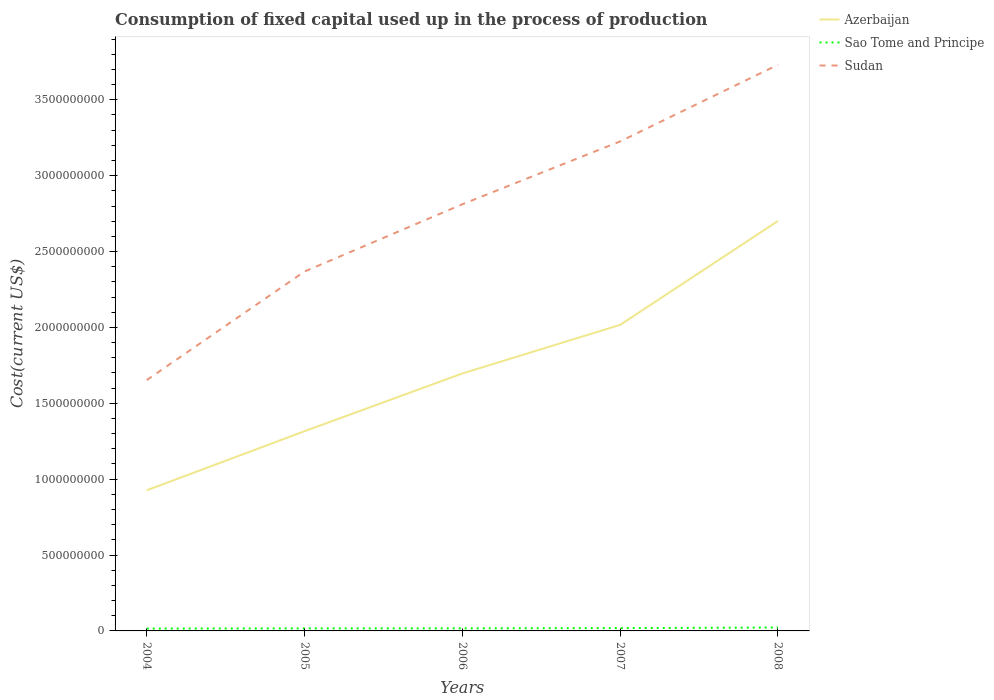Is the number of lines equal to the number of legend labels?
Your answer should be very brief. Yes. Across all years, what is the maximum amount consumed in the process of production in Sao Tome and Principe?
Your answer should be compact. 1.56e+07. What is the total amount consumed in the process of production in Sao Tome and Principe in the graph?
Keep it short and to the point. -6.07e+06. What is the difference between the highest and the second highest amount consumed in the process of production in Sao Tome and Principe?
Make the answer very short. 7.11e+06. What is the difference between the highest and the lowest amount consumed in the process of production in Sao Tome and Principe?
Give a very brief answer. 2. How many lines are there?
Your answer should be compact. 3. Does the graph contain any zero values?
Give a very brief answer. No. Does the graph contain grids?
Offer a very short reply. No. Where does the legend appear in the graph?
Your answer should be very brief. Top right. What is the title of the graph?
Keep it short and to the point. Consumption of fixed capital used up in the process of production. Does "Cameroon" appear as one of the legend labels in the graph?
Make the answer very short. No. What is the label or title of the Y-axis?
Offer a very short reply. Cost(current US$). What is the Cost(current US$) in Azerbaijan in 2004?
Give a very brief answer. 9.27e+08. What is the Cost(current US$) in Sao Tome and Principe in 2004?
Provide a succinct answer. 1.56e+07. What is the Cost(current US$) in Sudan in 2004?
Provide a succinct answer. 1.65e+09. What is the Cost(current US$) in Azerbaijan in 2005?
Your answer should be very brief. 1.32e+09. What is the Cost(current US$) in Sao Tome and Principe in 2005?
Make the answer very short. 1.66e+07. What is the Cost(current US$) in Sudan in 2005?
Offer a terse response. 2.37e+09. What is the Cost(current US$) of Azerbaijan in 2006?
Your answer should be very brief. 1.70e+09. What is the Cost(current US$) of Sao Tome and Principe in 2006?
Ensure brevity in your answer.  1.69e+07. What is the Cost(current US$) in Sudan in 2006?
Your answer should be very brief. 2.81e+09. What is the Cost(current US$) of Azerbaijan in 2007?
Provide a succinct answer. 2.02e+09. What is the Cost(current US$) of Sao Tome and Principe in 2007?
Give a very brief answer. 1.85e+07. What is the Cost(current US$) of Sudan in 2007?
Your answer should be compact. 3.23e+09. What is the Cost(current US$) of Azerbaijan in 2008?
Provide a short and direct response. 2.70e+09. What is the Cost(current US$) of Sao Tome and Principe in 2008?
Keep it short and to the point. 2.27e+07. What is the Cost(current US$) in Sudan in 2008?
Your answer should be very brief. 3.73e+09. Across all years, what is the maximum Cost(current US$) of Azerbaijan?
Give a very brief answer. 2.70e+09. Across all years, what is the maximum Cost(current US$) in Sao Tome and Principe?
Offer a very short reply. 2.27e+07. Across all years, what is the maximum Cost(current US$) of Sudan?
Offer a terse response. 3.73e+09. Across all years, what is the minimum Cost(current US$) of Azerbaijan?
Give a very brief answer. 9.27e+08. Across all years, what is the minimum Cost(current US$) of Sao Tome and Principe?
Your answer should be very brief. 1.56e+07. Across all years, what is the minimum Cost(current US$) in Sudan?
Your response must be concise. 1.65e+09. What is the total Cost(current US$) in Azerbaijan in the graph?
Ensure brevity in your answer.  8.66e+09. What is the total Cost(current US$) in Sao Tome and Principe in the graph?
Ensure brevity in your answer.  9.03e+07. What is the total Cost(current US$) of Sudan in the graph?
Your answer should be compact. 1.38e+1. What is the difference between the Cost(current US$) in Azerbaijan in 2004 and that in 2005?
Your answer should be compact. -3.89e+08. What is the difference between the Cost(current US$) in Sao Tome and Principe in 2004 and that in 2005?
Give a very brief answer. -1.04e+06. What is the difference between the Cost(current US$) in Sudan in 2004 and that in 2005?
Ensure brevity in your answer.  -7.15e+08. What is the difference between the Cost(current US$) of Azerbaijan in 2004 and that in 2006?
Your response must be concise. -7.70e+08. What is the difference between the Cost(current US$) in Sao Tome and Principe in 2004 and that in 2006?
Offer a terse response. -1.29e+06. What is the difference between the Cost(current US$) of Sudan in 2004 and that in 2006?
Keep it short and to the point. -1.16e+09. What is the difference between the Cost(current US$) in Azerbaijan in 2004 and that in 2007?
Provide a succinct answer. -1.09e+09. What is the difference between the Cost(current US$) of Sao Tome and Principe in 2004 and that in 2007?
Provide a succinct answer. -2.95e+06. What is the difference between the Cost(current US$) of Sudan in 2004 and that in 2007?
Make the answer very short. -1.57e+09. What is the difference between the Cost(current US$) of Azerbaijan in 2004 and that in 2008?
Ensure brevity in your answer.  -1.77e+09. What is the difference between the Cost(current US$) of Sao Tome and Principe in 2004 and that in 2008?
Give a very brief answer. -7.11e+06. What is the difference between the Cost(current US$) in Sudan in 2004 and that in 2008?
Your response must be concise. -2.08e+09. What is the difference between the Cost(current US$) in Azerbaijan in 2005 and that in 2006?
Your answer should be compact. -3.80e+08. What is the difference between the Cost(current US$) of Sao Tome and Principe in 2005 and that in 2006?
Make the answer very short. -2.56e+05. What is the difference between the Cost(current US$) in Sudan in 2005 and that in 2006?
Make the answer very short. -4.43e+08. What is the difference between the Cost(current US$) of Azerbaijan in 2005 and that in 2007?
Give a very brief answer. -7.01e+08. What is the difference between the Cost(current US$) of Sao Tome and Principe in 2005 and that in 2007?
Your response must be concise. -1.92e+06. What is the difference between the Cost(current US$) of Sudan in 2005 and that in 2007?
Provide a short and direct response. -8.57e+08. What is the difference between the Cost(current US$) of Azerbaijan in 2005 and that in 2008?
Your response must be concise. -1.39e+09. What is the difference between the Cost(current US$) of Sao Tome and Principe in 2005 and that in 2008?
Provide a short and direct response. -6.07e+06. What is the difference between the Cost(current US$) in Sudan in 2005 and that in 2008?
Give a very brief answer. -1.36e+09. What is the difference between the Cost(current US$) in Azerbaijan in 2006 and that in 2007?
Your answer should be compact. -3.20e+08. What is the difference between the Cost(current US$) of Sao Tome and Principe in 2006 and that in 2007?
Ensure brevity in your answer.  -1.66e+06. What is the difference between the Cost(current US$) of Sudan in 2006 and that in 2007?
Your response must be concise. -4.14e+08. What is the difference between the Cost(current US$) in Azerbaijan in 2006 and that in 2008?
Ensure brevity in your answer.  -1.01e+09. What is the difference between the Cost(current US$) in Sao Tome and Principe in 2006 and that in 2008?
Your response must be concise. -5.82e+06. What is the difference between the Cost(current US$) of Sudan in 2006 and that in 2008?
Your response must be concise. -9.19e+08. What is the difference between the Cost(current US$) in Azerbaijan in 2007 and that in 2008?
Keep it short and to the point. -6.85e+08. What is the difference between the Cost(current US$) in Sao Tome and Principe in 2007 and that in 2008?
Provide a succinct answer. -4.15e+06. What is the difference between the Cost(current US$) in Sudan in 2007 and that in 2008?
Offer a terse response. -5.05e+08. What is the difference between the Cost(current US$) in Azerbaijan in 2004 and the Cost(current US$) in Sao Tome and Principe in 2005?
Offer a very short reply. 9.10e+08. What is the difference between the Cost(current US$) of Azerbaijan in 2004 and the Cost(current US$) of Sudan in 2005?
Give a very brief answer. -1.44e+09. What is the difference between the Cost(current US$) in Sao Tome and Principe in 2004 and the Cost(current US$) in Sudan in 2005?
Give a very brief answer. -2.35e+09. What is the difference between the Cost(current US$) of Azerbaijan in 2004 and the Cost(current US$) of Sao Tome and Principe in 2006?
Ensure brevity in your answer.  9.10e+08. What is the difference between the Cost(current US$) in Azerbaijan in 2004 and the Cost(current US$) in Sudan in 2006?
Make the answer very short. -1.89e+09. What is the difference between the Cost(current US$) of Sao Tome and Principe in 2004 and the Cost(current US$) of Sudan in 2006?
Give a very brief answer. -2.80e+09. What is the difference between the Cost(current US$) of Azerbaijan in 2004 and the Cost(current US$) of Sao Tome and Principe in 2007?
Provide a succinct answer. 9.08e+08. What is the difference between the Cost(current US$) of Azerbaijan in 2004 and the Cost(current US$) of Sudan in 2007?
Ensure brevity in your answer.  -2.30e+09. What is the difference between the Cost(current US$) of Sao Tome and Principe in 2004 and the Cost(current US$) of Sudan in 2007?
Provide a short and direct response. -3.21e+09. What is the difference between the Cost(current US$) in Azerbaijan in 2004 and the Cost(current US$) in Sao Tome and Principe in 2008?
Ensure brevity in your answer.  9.04e+08. What is the difference between the Cost(current US$) of Azerbaijan in 2004 and the Cost(current US$) of Sudan in 2008?
Ensure brevity in your answer.  -2.80e+09. What is the difference between the Cost(current US$) in Sao Tome and Principe in 2004 and the Cost(current US$) in Sudan in 2008?
Offer a very short reply. -3.72e+09. What is the difference between the Cost(current US$) of Azerbaijan in 2005 and the Cost(current US$) of Sao Tome and Principe in 2006?
Give a very brief answer. 1.30e+09. What is the difference between the Cost(current US$) in Azerbaijan in 2005 and the Cost(current US$) in Sudan in 2006?
Your answer should be compact. -1.50e+09. What is the difference between the Cost(current US$) in Sao Tome and Principe in 2005 and the Cost(current US$) in Sudan in 2006?
Your answer should be very brief. -2.80e+09. What is the difference between the Cost(current US$) in Azerbaijan in 2005 and the Cost(current US$) in Sao Tome and Principe in 2007?
Your response must be concise. 1.30e+09. What is the difference between the Cost(current US$) in Azerbaijan in 2005 and the Cost(current US$) in Sudan in 2007?
Provide a short and direct response. -1.91e+09. What is the difference between the Cost(current US$) in Sao Tome and Principe in 2005 and the Cost(current US$) in Sudan in 2007?
Offer a very short reply. -3.21e+09. What is the difference between the Cost(current US$) in Azerbaijan in 2005 and the Cost(current US$) in Sao Tome and Principe in 2008?
Provide a short and direct response. 1.29e+09. What is the difference between the Cost(current US$) of Azerbaijan in 2005 and the Cost(current US$) of Sudan in 2008?
Your answer should be compact. -2.41e+09. What is the difference between the Cost(current US$) in Sao Tome and Principe in 2005 and the Cost(current US$) in Sudan in 2008?
Ensure brevity in your answer.  -3.71e+09. What is the difference between the Cost(current US$) of Azerbaijan in 2006 and the Cost(current US$) of Sao Tome and Principe in 2007?
Your answer should be very brief. 1.68e+09. What is the difference between the Cost(current US$) of Azerbaijan in 2006 and the Cost(current US$) of Sudan in 2007?
Offer a very short reply. -1.53e+09. What is the difference between the Cost(current US$) in Sao Tome and Principe in 2006 and the Cost(current US$) in Sudan in 2007?
Provide a succinct answer. -3.21e+09. What is the difference between the Cost(current US$) in Azerbaijan in 2006 and the Cost(current US$) in Sao Tome and Principe in 2008?
Ensure brevity in your answer.  1.67e+09. What is the difference between the Cost(current US$) of Azerbaijan in 2006 and the Cost(current US$) of Sudan in 2008?
Your answer should be compact. -2.03e+09. What is the difference between the Cost(current US$) in Sao Tome and Principe in 2006 and the Cost(current US$) in Sudan in 2008?
Your answer should be very brief. -3.71e+09. What is the difference between the Cost(current US$) in Azerbaijan in 2007 and the Cost(current US$) in Sao Tome and Principe in 2008?
Your response must be concise. 1.99e+09. What is the difference between the Cost(current US$) in Azerbaijan in 2007 and the Cost(current US$) in Sudan in 2008?
Your response must be concise. -1.71e+09. What is the difference between the Cost(current US$) in Sao Tome and Principe in 2007 and the Cost(current US$) in Sudan in 2008?
Your answer should be compact. -3.71e+09. What is the average Cost(current US$) of Azerbaijan per year?
Offer a very short reply. 1.73e+09. What is the average Cost(current US$) of Sao Tome and Principe per year?
Provide a succinct answer. 1.81e+07. What is the average Cost(current US$) of Sudan per year?
Your response must be concise. 2.76e+09. In the year 2004, what is the difference between the Cost(current US$) of Azerbaijan and Cost(current US$) of Sao Tome and Principe?
Your response must be concise. 9.11e+08. In the year 2004, what is the difference between the Cost(current US$) in Azerbaijan and Cost(current US$) in Sudan?
Provide a short and direct response. -7.26e+08. In the year 2004, what is the difference between the Cost(current US$) in Sao Tome and Principe and Cost(current US$) in Sudan?
Offer a terse response. -1.64e+09. In the year 2005, what is the difference between the Cost(current US$) of Azerbaijan and Cost(current US$) of Sao Tome and Principe?
Offer a very short reply. 1.30e+09. In the year 2005, what is the difference between the Cost(current US$) of Azerbaijan and Cost(current US$) of Sudan?
Provide a succinct answer. -1.05e+09. In the year 2005, what is the difference between the Cost(current US$) of Sao Tome and Principe and Cost(current US$) of Sudan?
Your response must be concise. -2.35e+09. In the year 2006, what is the difference between the Cost(current US$) of Azerbaijan and Cost(current US$) of Sao Tome and Principe?
Give a very brief answer. 1.68e+09. In the year 2006, what is the difference between the Cost(current US$) of Azerbaijan and Cost(current US$) of Sudan?
Keep it short and to the point. -1.12e+09. In the year 2006, what is the difference between the Cost(current US$) of Sao Tome and Principe and Cost(current US$) of Sudan?
Your response must be concise. -2.79e+09. In the year 2007, what is the difference between the Cost(current US$) of Azerbaijan and Cost(current US$) of Sao Tome and Principe?
Provide a succinct answer. 2.00e+09. In the year 2007, what is the difference between the Cost(current US$) in Azerbaijan and Cost(current US$) in Sudan?
Provide a succinct answer. -1.21e+09. In the year 2007, what is the difference between the Cost(current US$) in Sao Tome and Principe and Cost(current US$) in Sudan?
Your response must be concise. -3.21e+09. In the year 2008, what is the difference between the Cost(current US$) of Azerbaijan and Cost(current US$) of Sao Tome and Principe?
Keep it short and to the point. 2.68e+09. In the year 2008, what is the difference between the Cost(current US$) of Azerbaijan and Cost(current US$) of Sudan?
Give a very brief answer. -1.03e+09. In the year 2008, what is the difference between the Cost(current US$) of Sao Tome and Principe and Cost(current US$) of Sudan?
Ensure brevity in your answer.  -3.71e+09. What is the ratio of the Cost(current US$) of Azerbaijan in 2004 to that in 2005?
Your response must be concise. 0.7. What is the ratio of the Cost(current US$) of Sao Tome and Principe in 2004 to that in 2005?
Your answer should be compact. 0.94. What is the ratio of the Cost(current US$) in Sudan in 2004 to that in 2005?
Your answer should be very brief. 0.7. What is the ratio of the Cost(current US$) of Azerbaijan in 2004 to that in 2006?
Your response must be concise. 0.55. What is the ratio of the Cost(current US$) in Sao Tome and Principe in 2004 to that in 2006?
Make the answer very short. 0.92. What is the ratio of the Cost(current US$) of Sudan in 2004 to that in 2006?
Provide a short and direct response. 0.59. What is the ratio of the Cost(current US$) of Azerbaijan in 2004 to that in 2007?
Give a very brief answer. 0.46. What is the ratio of the Cost(current US$) of Sao Tome and Principe in 2004 to that in 2007?
Provide a succinct answer. 0.84. What is the ratio of the Cost(current US$) in Sudan in 2004 to that in 2007?
Give a very brief answer. 0.51. What is the ratio of the Cost(current US$) of Azerbaijan in 2004 to that in 2008?
Your answer should be compact. 0.34. What is the ratio of the Cost(current US$) of Sao Tome and Principe in 2004 to that in 2008?
Your answer should be very brief. 0.69. What is the ratio of the Cost(current US$) in Sudan in 2004 to that in 2008?
Provide a succinct answer. 0.44. What is the ratio of the Cost(current US$) of Azerbaijan in 2005 to that in 2006?
Offer a very short reply. 0.78. What is the ratio of the Cost(current US$) in Sudan in 2005 to that in 2006?
Give a very brief answer. 0.84. What is the ratio of the Cost(current US$) in Azerbaijan in 2005 to that in 2007?
Your answer should be very brief. 0.65. What is the ratio of the Cost(current US$) of Sao Tome and Principe in 2005 to that in 2007?
Provide a short and direct response. 0.9. What is the ratio of the Cost(current US$) in Sudan in 2005 to that in 2007?
Offer a very short reply. 0.73. What is the ratio of the Cost(current US$) in Azerbaijan in 2005 to that in 2008?
Make the answer very short. 0.49. What is the ratio of the Cost(current US$) in Sao Tome and Principe in 2005 to that in 2008?
Give a very brief answer. 0.73. What is the ratio of the Cost(current US$) in Sudan in 2005 to that in 2008?
Make the answer very short. 0.63. What is the ratio of the Cost(current US$) of Azerbaijan in 2006 to that in 2007?
Offer a terse response. 0.84. What is the ratio of the Cost(current US$) of Sao Tome and Principe in 2006 to that in 2007?
Keep it short and to the point. 0.91. What is the ratio of the Cost(current US$) in Sudan in 2006 to that in 2007?
Make the answer very short. 0.87. What is the ratio of the Cost(current US$) of Azerbaijan in 2006 to that in 2008?
Your answer should be very brief. 0.63. What is the ratio of the Cost(current US$) of Sao Tome and Principe in 2006 to that in 2008?
Offer a terse response. 0.74. What is the ratio of the Cost(current US$) in Sudan in 2006 to that in 2008?
Your answer should be compact. 0.75. What is the ratio of the Cost(current US$) of Azerbaijan in 2007 to that in 2008?
Your response must be concise. 0.75. What is the ratio of the Cost(current US$) in Sao Tome and Principe in 2007 to that in 2008?
Provide a short and direct response. 0.82. What is the ratio of the Cost(current US$) of Sudan in 2007 to that in 2008?
Your answer should be compact. 0.86. What is the difference between the highest and the second highest Cost(current US$) of Azerbaijan?
Your answer should be compact. 6.85e+08. What is the difference between the highest and the second highest Cost(current US$) of Sao Tome and Principe?
Provide a succinct answer. 4.15e+06. What is the difference between the highest and the second highest Cost(current US$) in Sudan?
Provide a succinct answer. 5.05e+08. What is the difference between the highest and the lowest Cost(current US$) in Azerbaijan?
Your answer should be compact. 1.77e+09. What is the difference between the highest and the lowest Cost(current US$) of Sao Tome and Principe?
Offer a very short reply. 7.11e+06. What is the difference between the highest and the lowest Cost(current US$) of Sudan?
Provide a short and direct response. 2.08e+09. 